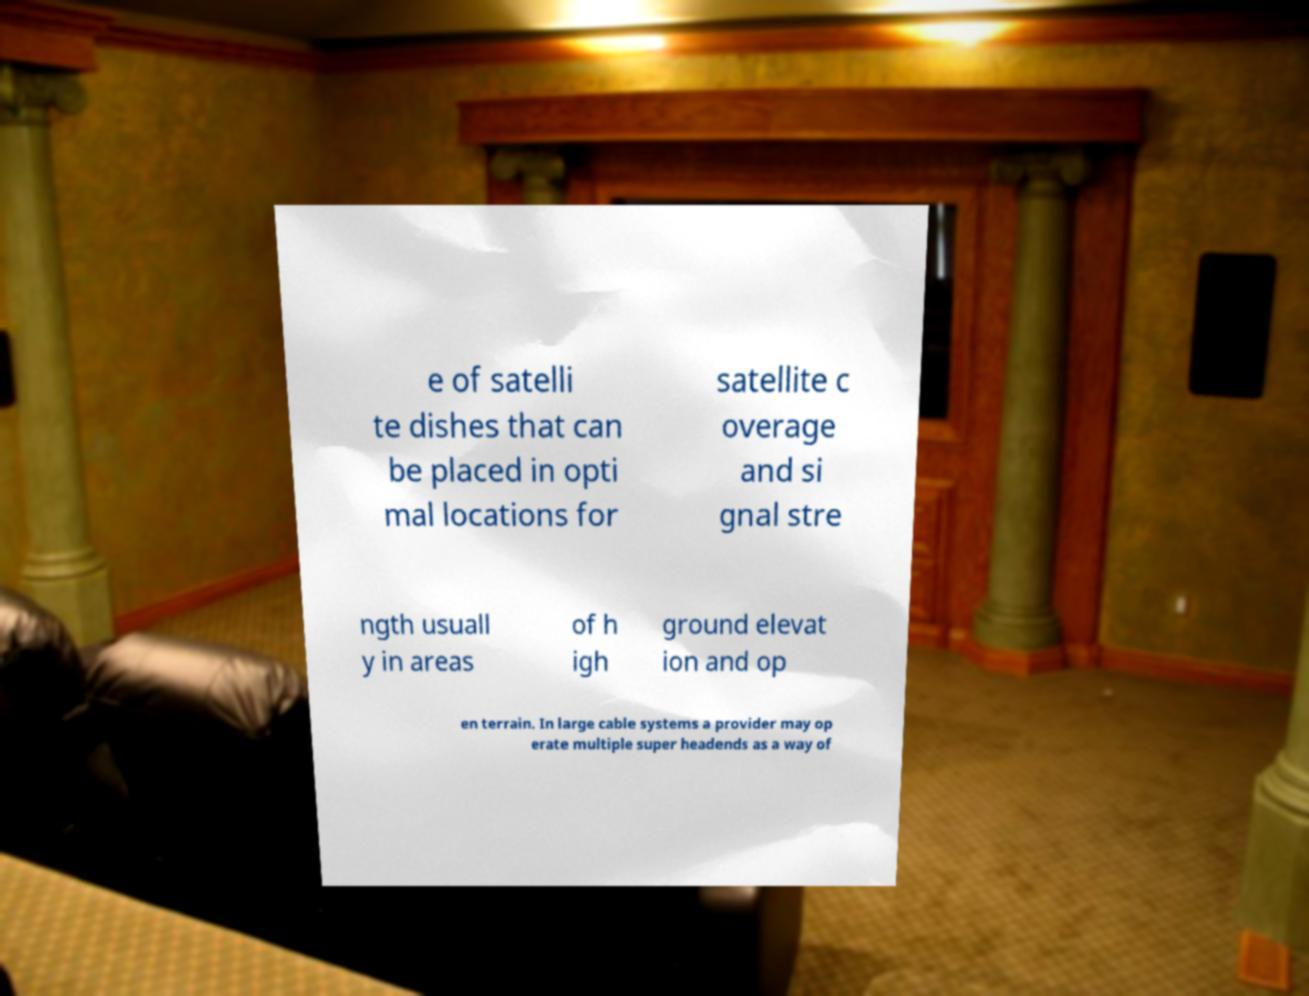Please read and relay the text visible in this image. What does it say? e of satelli te dishes that can be placed in opti mal locations for satellite c overage and si gnal stre ngth usuall y in areas of h igh ground elevat ion and op en terrain. In large cable systems a provider may op erate multiple super headends as a way of 